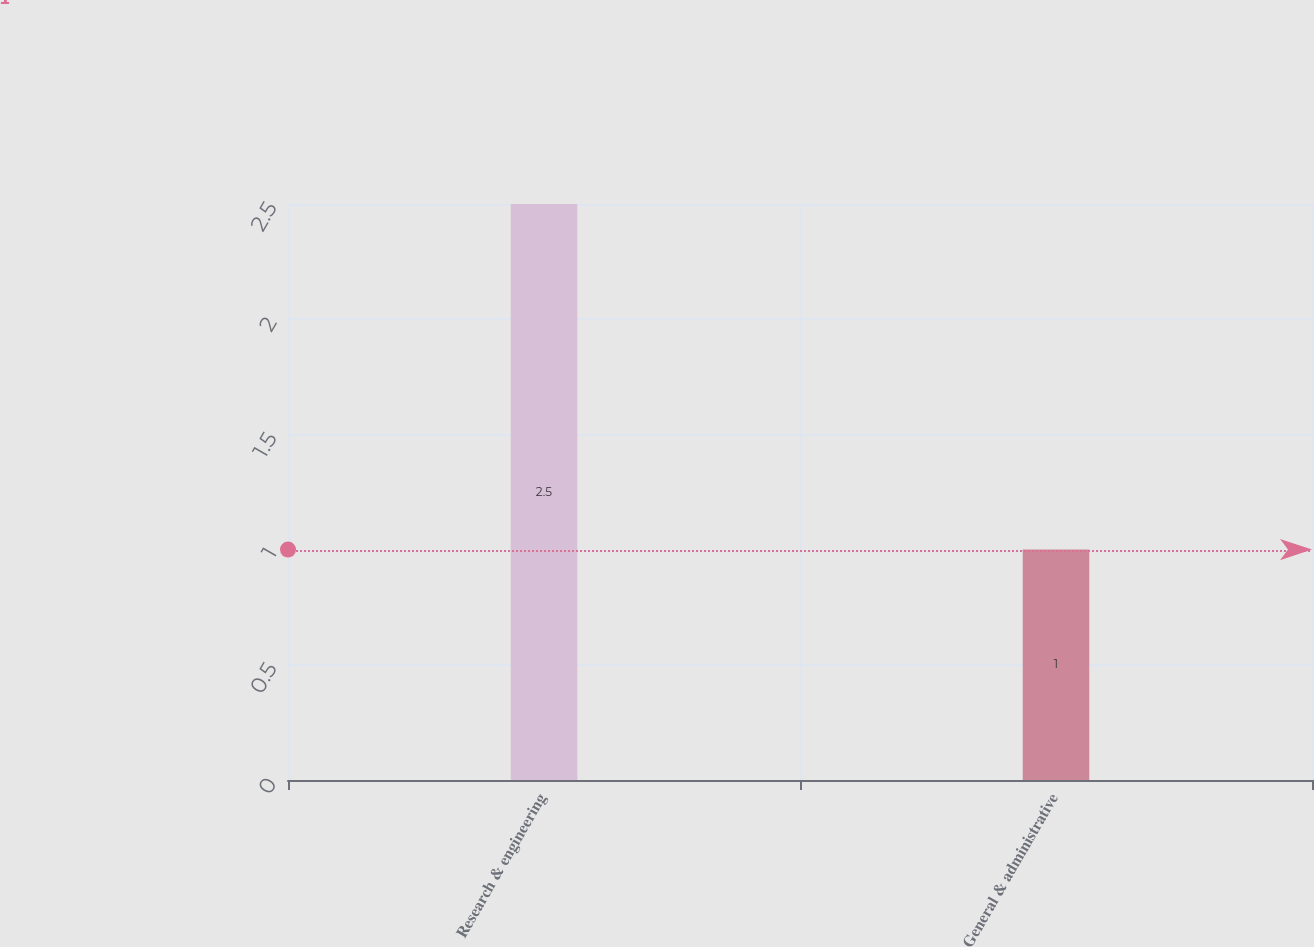Convert chart to OTSL. <chart><loc_0><loc_0><loc_500><loc_500><bar_chart><fcel>Research & engineering<fcel>General & administrative<nl><fcel>2.5<fcel>1<nl></chart> 